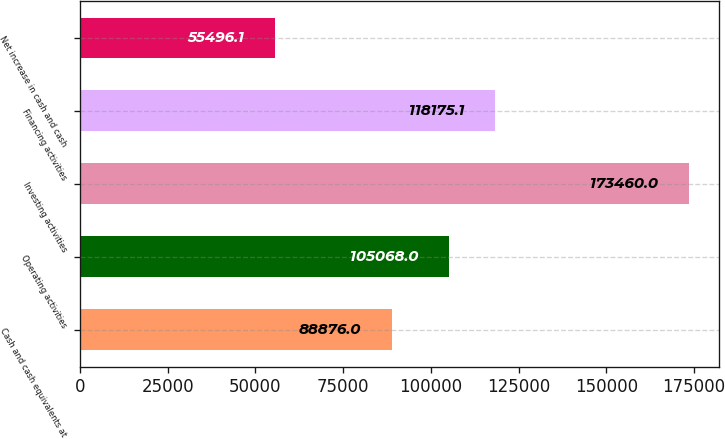Convert chart to OTSL. <chart><loc_0><loc_0><loc_500><loc_500><bar_chart><fcel>Cash and cash equivalents at<fcel>Operating activities<fcel>Investing activities<fcel>Financing activities<fcel>Net increase in cash and cash<nl><fcel>88876<fcel>105068<fcel>173460<fcel>118175<fcel>55496.1<nl></chart> 